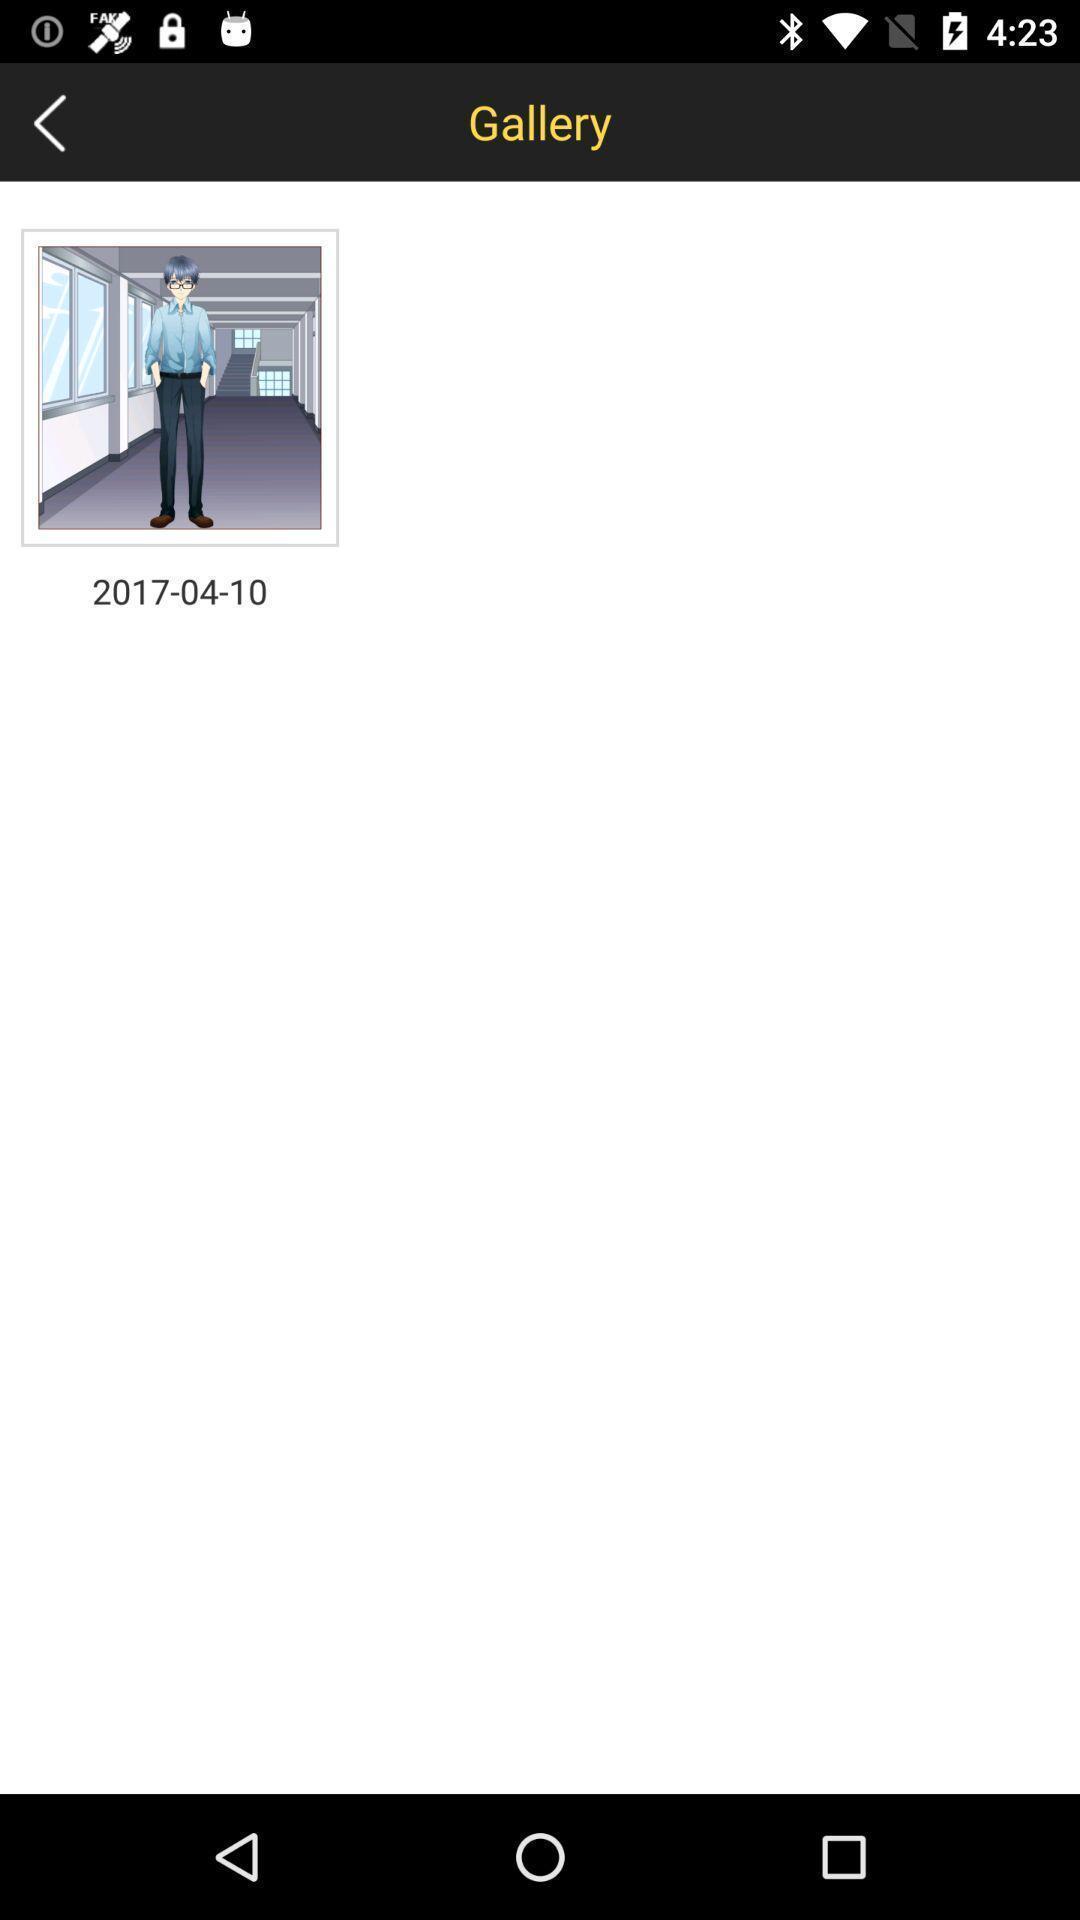What is the overall content of this screenshot? Page displaying with a image. 